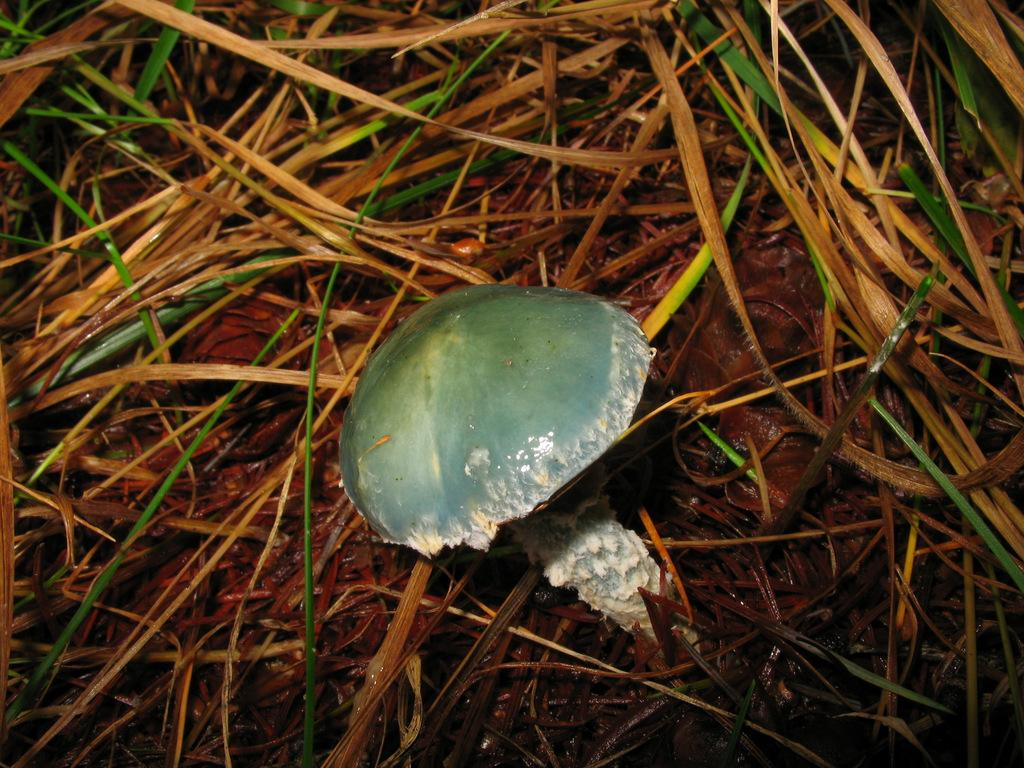What type of plant can be seen in the image? There is a mushroom in the image. What type of vegetation is present in the image? There is grass in the image. What route does the family take to reach the mushroom in the image? There is no family or route present in the image; it only features a mushroom and grass. What is the answer to the question about the mushroom's color in the image? The provided facts do not mention the color of the mushroom, so we cannot answer this question based on the given information. 